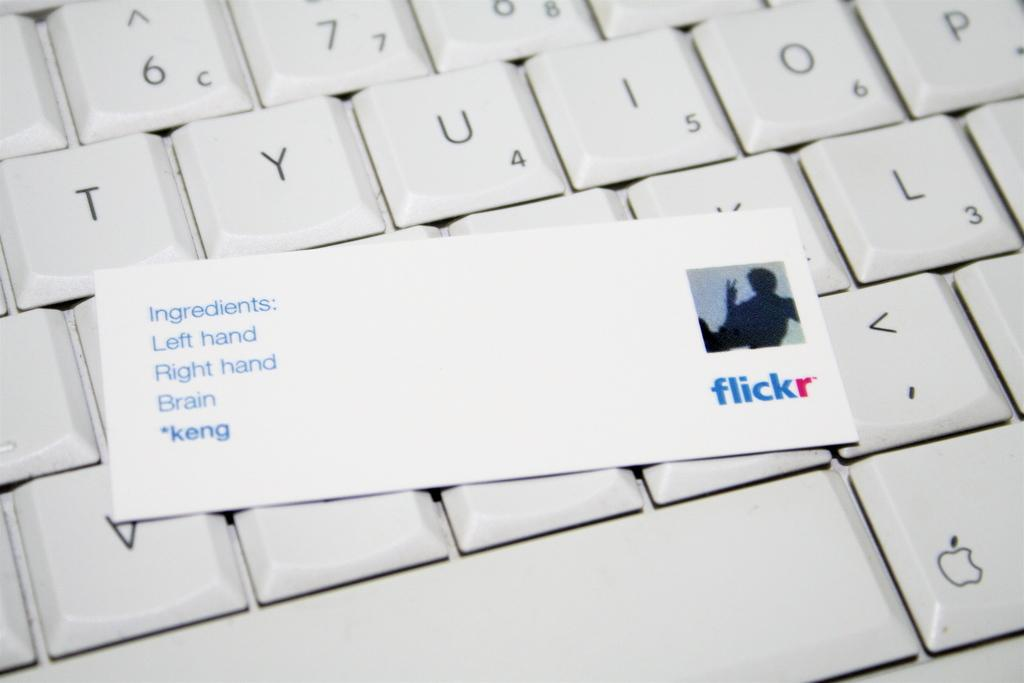<image>
Offer a succinct explanation of the picture presented. A card for flickr says Ingredients: Left Hand, Right Hand, Brain, *keng and is laid on top of a keyboard. 